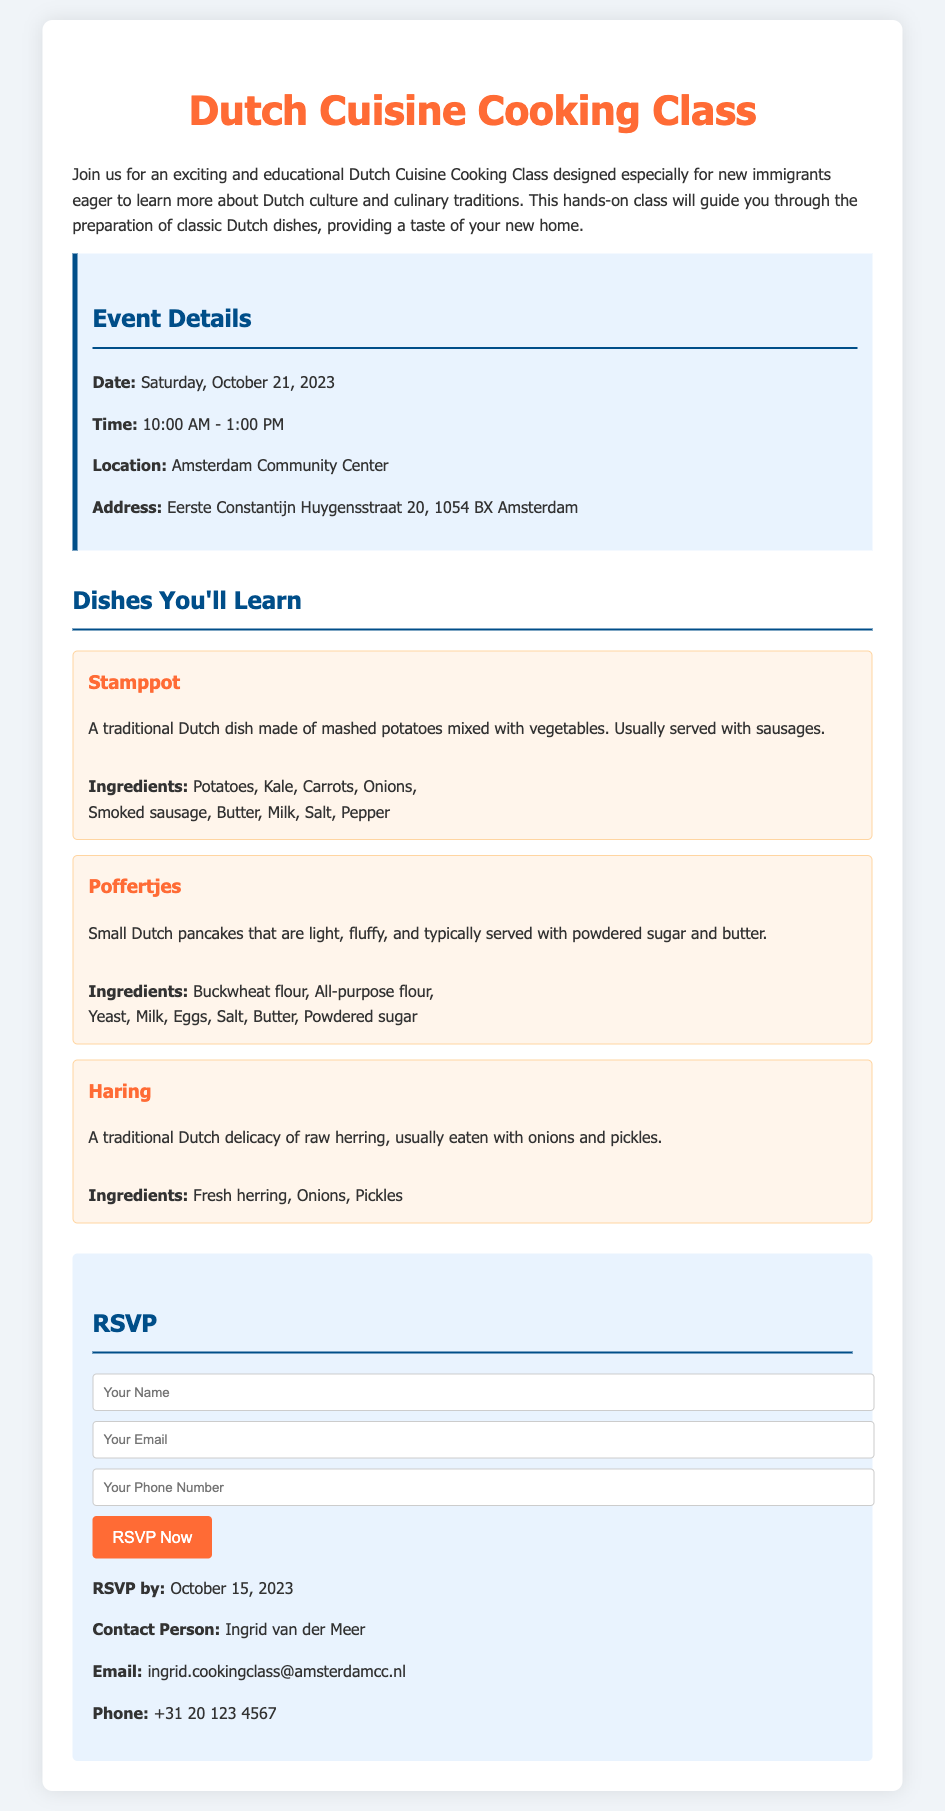What is the title of the event? The title of the event is stated at the top of the document.
Answer: Dutch Cuisine Cooking Class What is the address of the location? The address is provided in the event details section.
Answer: Eerste Constantijn Huygensstraat 20, 1054 BX Amsterdam Who is the contact person for the RSVP? The contact person is mentioned in the RSVP section of the document.
Answer: Ingrid van der Meer When must you RSVP by? The RSVP deadline is specified in the RSVP section.
Answer: October 15, 2023 What dish is made with mashed potatoes and vegetables? This dish is one of the three highlighted dishes in the document.
Answer: Stamppot How many different dishes will be learned in the class? The document lists three dishes that will be learned in the class.
Answer: Three What are the ingredients for Poffertjes? The ingredients are detailed under the specific dish section for Poffertjes.
Answer: Buckwheat flour, All-purpose flour, Yeast, Milk, Eggs, Salt, Butter, Powdered sugar What time does the cooking class start? The starting time is given in the event details section of the document.
Answer: 10:00 AM What is the main ingredient in Haring? The main ingredient is stated clearly under the Haring dish description.
Answer: Fresh herring 